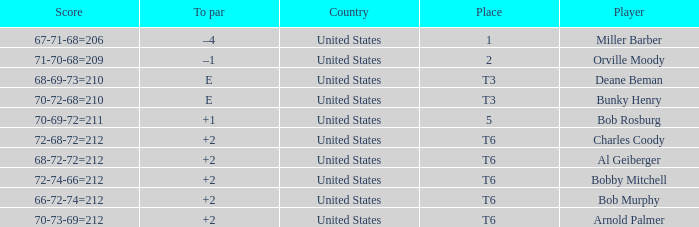What is the score of player bob rosburg? 70-69-72=211. 